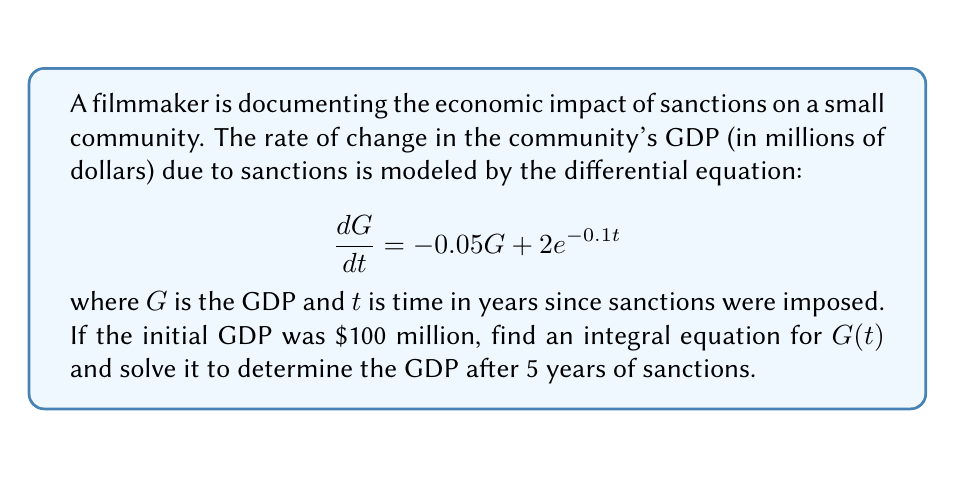Help me with this question. 1) First, we need to set up the integral equation. Rearranging the differential equation:

   $$dG = (-0.05G + 2e^{-0.1t})dt$$

2) Integrating both sides from 0 to t:

   $$\int_0^t dG = \int_0^t (-0.05G + 2e^{-0.1t})dt$$

3) This gives us the integral equation:

   $$G(t) - G(0) = -0.05\int_0^t G(s)ds + 2\int_0^t e^{-0.1s}ds$$

4) We know that $G(0) = 100$, so:

   $$G(t) = 100 - 0.05\int_0^t G(s)ds + 2\int_0^t e^{-0.1s}ds$$

5) To solve this, we can differentiate both sides:

   $$\frac{dG}{dt} = -0.05G(t) + 2e^{-0.1t}$$

6) This is our original differential equation. We can solve it using the integrating factor method. The integrating factor is $e^{0.05t}$:

   $$\frac{d}{dt}(Ge^{0.05t}) = 2e^{-0.05t}$$

7) Integrating both sides:

   $$Ge^{0.05t} = -40e^{-0.05t} + C$$

8) Using the initial condition $G(0) = 100$:

   $$100 = -40 + C \implies C = 140$$

9) Therefore, the solution is:

   $$G(t) = 140e^{-0.05t} - 40$$

10) To find GDP after 5 years, we evaluate $G(5)$:

    $$G(5) = 140e^{-0.05(5)} - 40 \approx 70.0$$
Answer: $G(t) = 140e^{-0.05t} - 40$; GDP after 5 years ≈ $70.0 million 